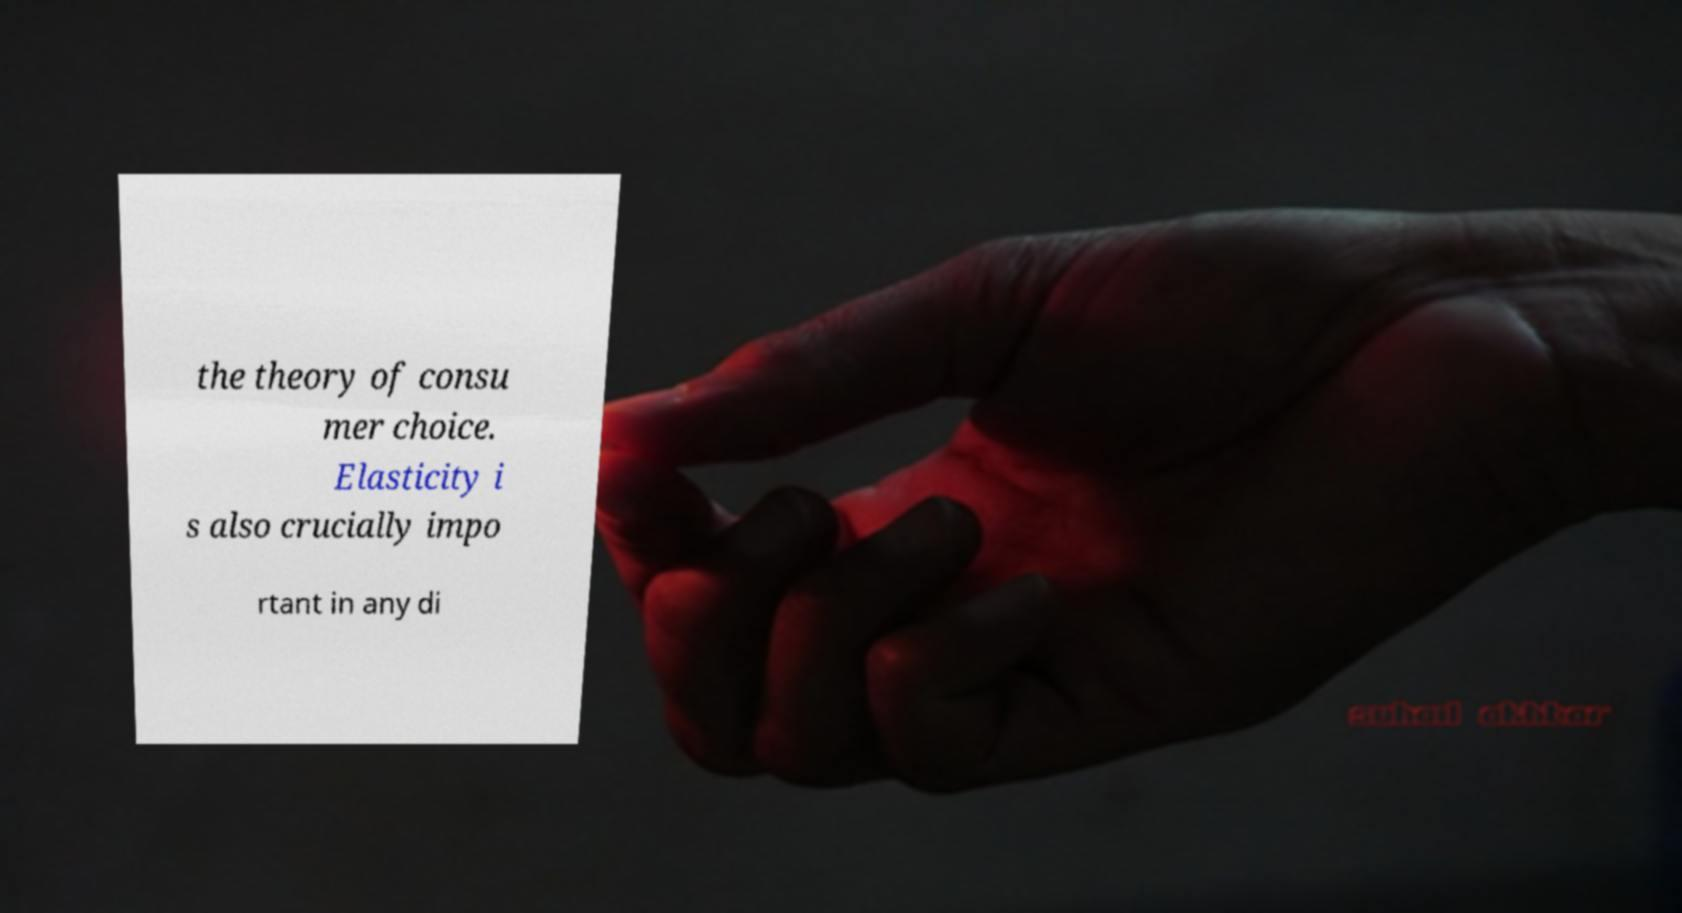For documentation purposes, I need the text within this image transcribed. Could you provide that? the theory of consu mer choice. Elasticity i s also crucially impo rtant in any di 